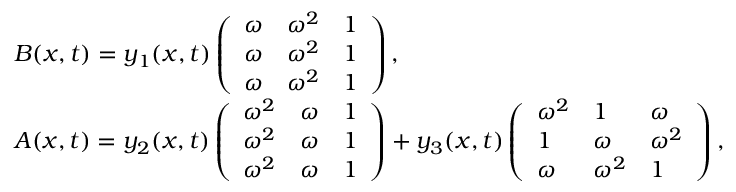Convert formula to latex. <formula><loc_0><loc_0><loc_500><loc_500>\begin{array} { r l } & { B ( x , t ) = y _ { 1 } ( x , t ) \left ( \begin{array} { l l l } { \omega } & { \omega ^ { 2 } } & { 1 } \\ { \omega } & { \omega ^ { 2 } } & { 1 } \\ { \omega } & { \omega ^ { 2 } } & { 1 } \end{array} \right ) , } \\ & { A ( x , t ) = y _ { 2 } ( x , t ) \left ( \begin{array} { l l l } { \omega ^ { 2 } } & { \omega } & { 1 } \\ { \omega ^ { 2 } } & { \omega } & { 1 } \\ { \omega ^ { 2 } } & { \omega } & { 1 } \end{array} \right ) + y _ { 3 } ( x , t ) \left ( \begin{array} { l l l } { \omega ^ { 2 } } & { 1 } & { \omega } \\ { 1 } & { \omega } & { \omega ^ { 2 } } \\ { \omega } & { \omega ^ { 2 } } & { 1 } \end{array} \right ) , } \end{array}</formula> 